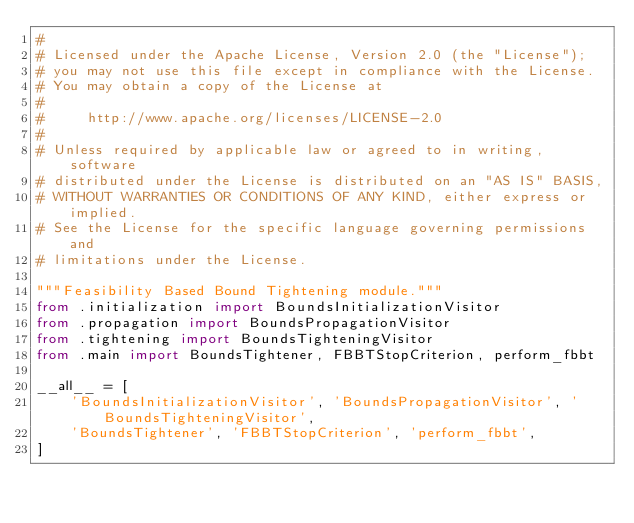<code> <loc_0><loc_0><loc_500><loc_500><_Python_>#
# Licensed under the Apache License, Version 2.0 (the "License");
# you may not use this file except in compliance with the License.
# You may obtain a copy of the License at
#
#     http://www.apache.org/licenses/LICENSE-2.0
#
# Unless required by applicable law or agreed to in writing, software
# distributed under the License is distributed on an "AS IS" BASIS,
# WITHOUT WARRANTIES OR CONDITIONS OF ANY KIND, either express or implied.
# See the License for the specific language governing permissions and
# limitations under the License.

"""Feasibility Based Bound Tightening module."""
from .initialization import BoundsInitializationVisitor
from .propagation import BoundsPropagationVisitor
from .tightening import BoundsTighteningVisitor
from .main import BoundsTightener, FBBTStopCriterion, perform_fbbt

__all__ = [
    'BoundsInitializationVisitor', 'BoundsPropagationVisitor', 'BoundsTighteningVisitor',
    'BoundsTightener', 'FBBTStopCriterion', 'perform_fbbt',
]
</code> 